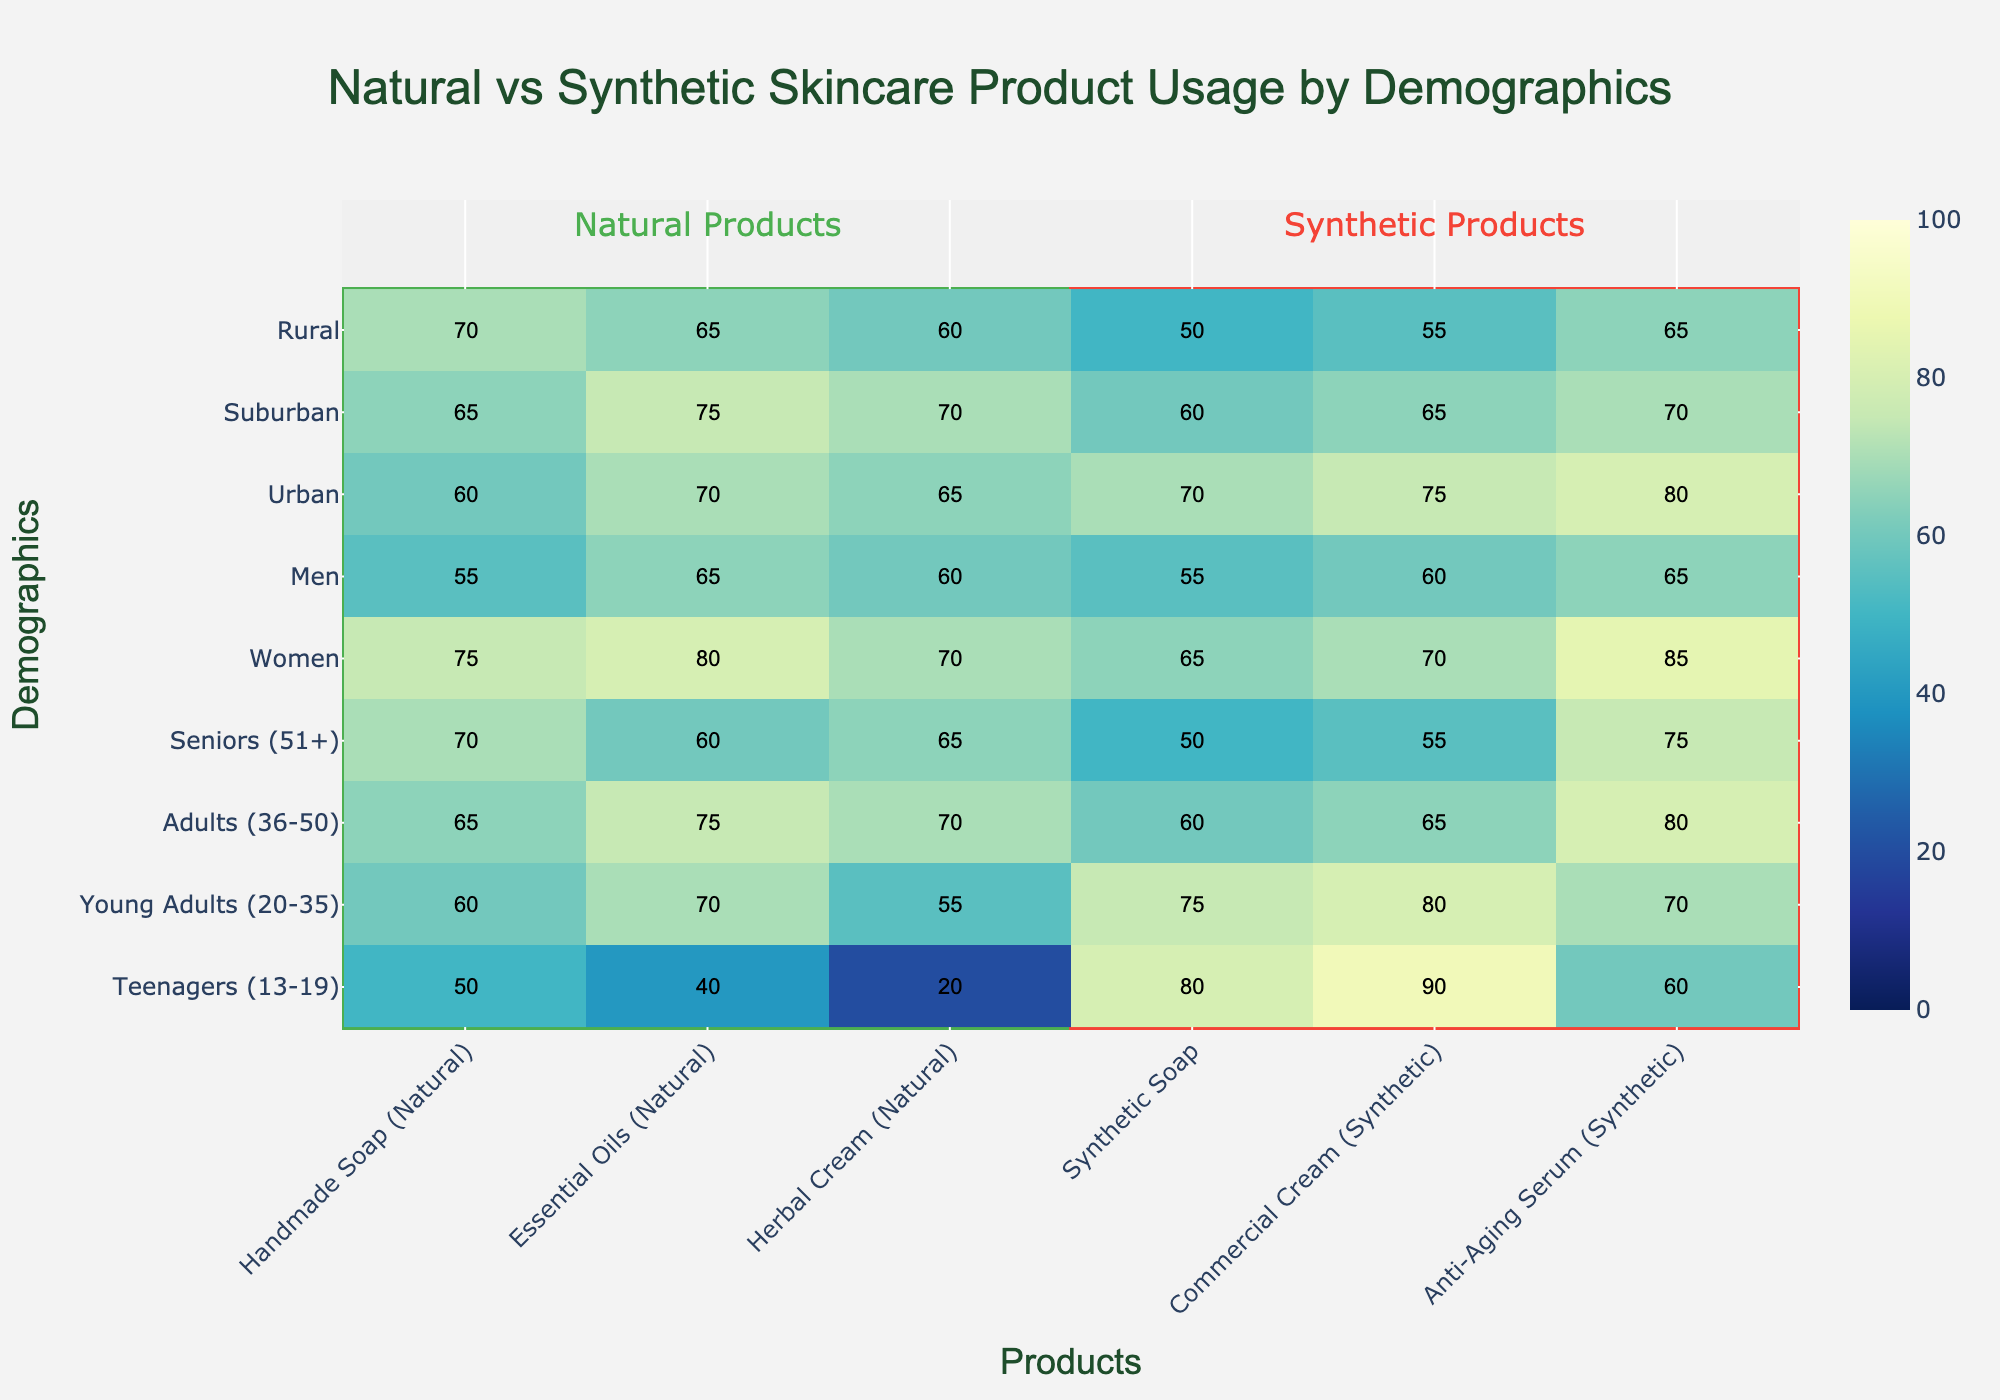What's the title of the heatmap? The title can be found at the top center of the heatmap. It should be explicitly stated in a larger font than other text.
Answer: Natural vs Synthetic Skincare Product Usage by Demographics Which demographic has the highest usage of handmade soap (natural)? Find the column corresponding to "Handmade Soap (Natural)" and look for the highest value. Then, identify the associated demographic.
Answer: Women What is the overall trend in product usage for rural demographics? Locate the row for "Rural". Observe the usage values across all products to identify if they tend to be high or low.
Answer: Higher usage of natural products, lower usage of synthetic products Compare the usage of essential oils (natural) between men and women. Find the usage value for "Essential Oils (Natural)" for both "Men" and "Women". Compare the two values.
Answer: Women have higher usage (80) compared to men (65) Which product has the least variation in usage across different demographics? Calculate the range (difference between maximum and minimum values) for each product's column. The product with the smallest range has the least variation.
Answer: Commercial Cream (Synthetic) How many demographic segments are included in the heatmap? Count the number of rows displayed on the y-axis of the heatmap.
Answer: 9 Is there any product that no demographic uses more than 50%? Check each product's column to see if all values stay below 50. If all values for a product are below 50, it fits the condition.
Answer: No Which demographic shows the lowest usage of synthetic soap? Locate the column for "Synthetic Soap" and find the smallest value. Identify the associated demographic.
Answer: Seniors (51+) What is the combined usage of anti-aging serum (synthetic) for young adults and adults? Look up the values for "Anti-Aging Serum (Synthetic)" for "Young Adults (20-35)" and "Adults (36-50)". Sum these values.
Answer: 70 + 80 = 150 Does urban or suburban demographic show higher usage of anti-aging serum (synthetic)? Compare the usage values for "Anti-Aging Serum (Synthetic)" for both "Urban" and "Suburban".
Answer: Urban (80) 